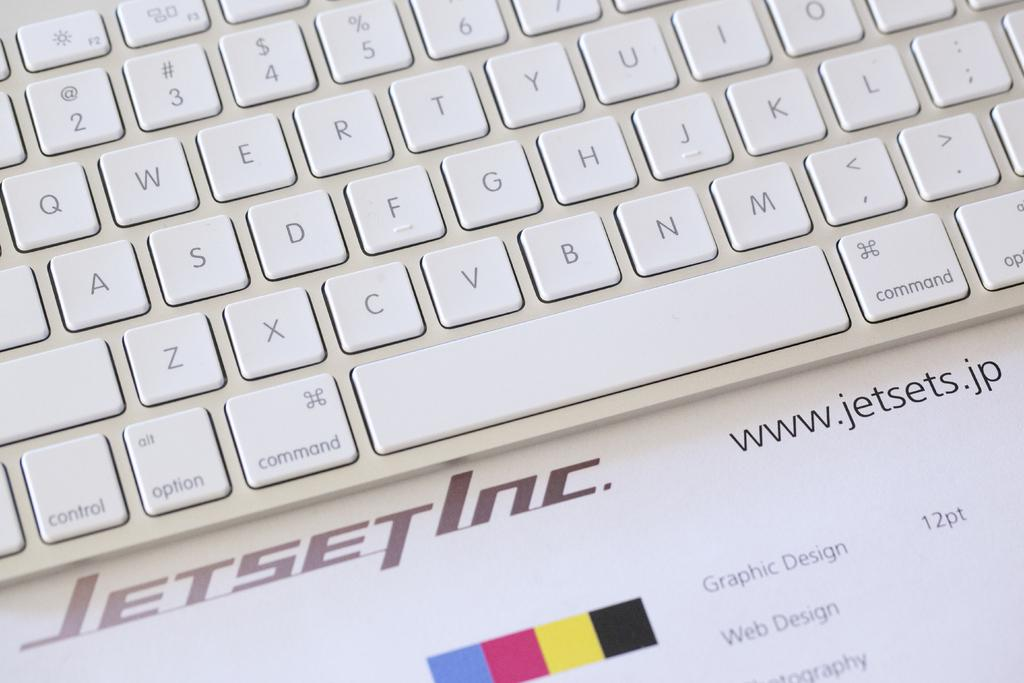<image>
Present a compact description of the photo's key features. A close up of the bottom right portion of a  white Jetset keyboard. 